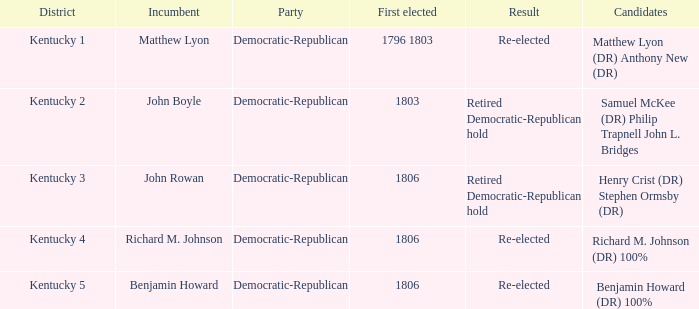Name the number of party for kentucky 1 1.0. 